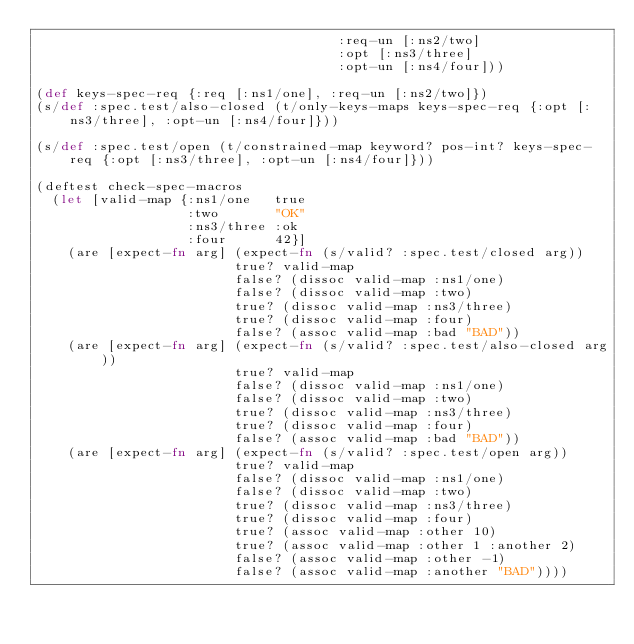<code> <loc_0><loc_0><loc_500><loc_500><_Clojure_>                                      :req-un [:ns2/two]
                                      :opt [:ns3/three]
                                      :opt-un [:ns4/four]))

(def keys-spec-req {:req [:ns1/one], :req-un [:ns2/two]})
(s/def :spec.test/also-closed (t/only-keys-maps keys-spec-req {:opt [:ns3/three], :opt-un [:ns4/four]}))

(s/def :spec.test/open (t/constrained-map keyword? pos-int? keys-spec-req {:opt [:ns3/three], :opt-un [:ns4/four]}))

(deftest check-spec-macros
  (let [valid-map {:ns1/one   true
                   :two       "OK"
                   :ns3/three :ok
                   :four      42}]
    (are [expect-fn arg] (expect-fn (s/valid? :spec.test/closed arg))
                         true? valid-map
                         false? (dissoc valid-map :ns1/one)
                         false? (dissoc valid-map :two)
                         true? (dissoc valid-map :ns3/three)
                         true? (dissoc valid-map :four)
                         false? (assoc valid-map :bad "BAD"))
    (are [expect-fn arg] (expect-fn (s/valid? :spec.test/also-closed arg))
                         true? valid-map
                         false? (dissoc valid-map :ns1/one)
                         false? (dissoc valid-map :two)
                         true? (dissoc valid-map :ns3/three)
                         true? (dissoc valid-map :four)
                         false? (assoc valid-map :bad "BAD"))
    (are [expect-fn arg] (expect-fn (s/valid? :spec.test/open arg))
                         true? valid-map
                         false? (dissoc valid-map :ns1/one)
                         false? (dissoc valid-map :two)
                         true? (dissoc valid-map :ns3/three)
                         true? (dissoc valid-map :four)
                         true? (assoc valid-map :other 10)
                         true? (assoc valid-map :other 1 :another 2)
                         false? (assoc valid-map :other -1)
                         false? (assoc valid-map :another "BAD"))))

</code> 